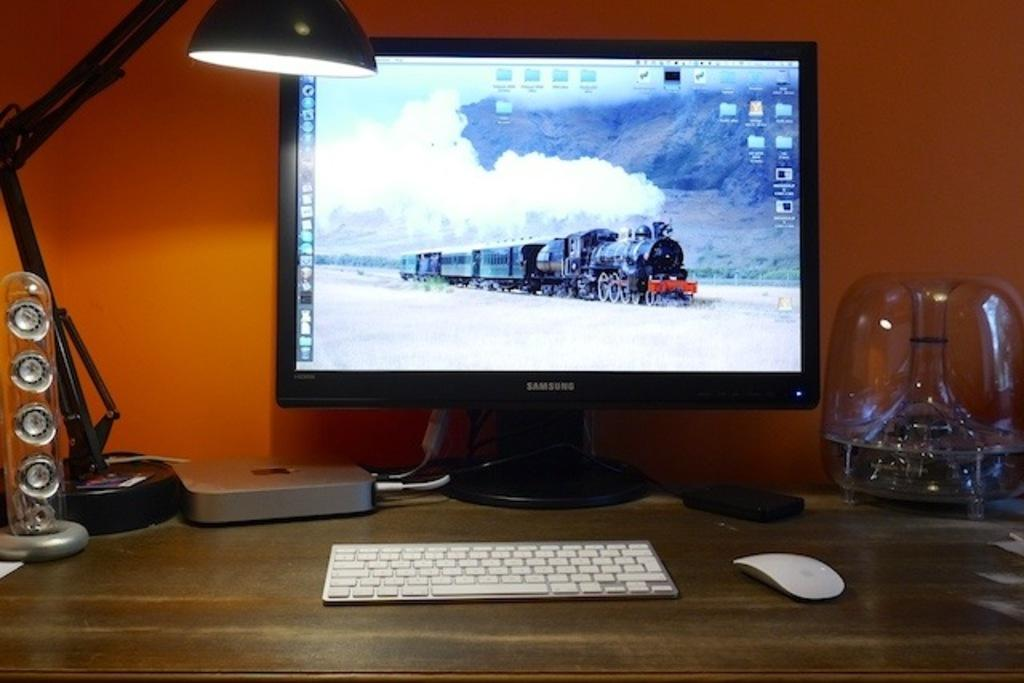<image>
Write a terse but informative summary of the picture. A Samsung computer has a picture of a train on the desktop. 